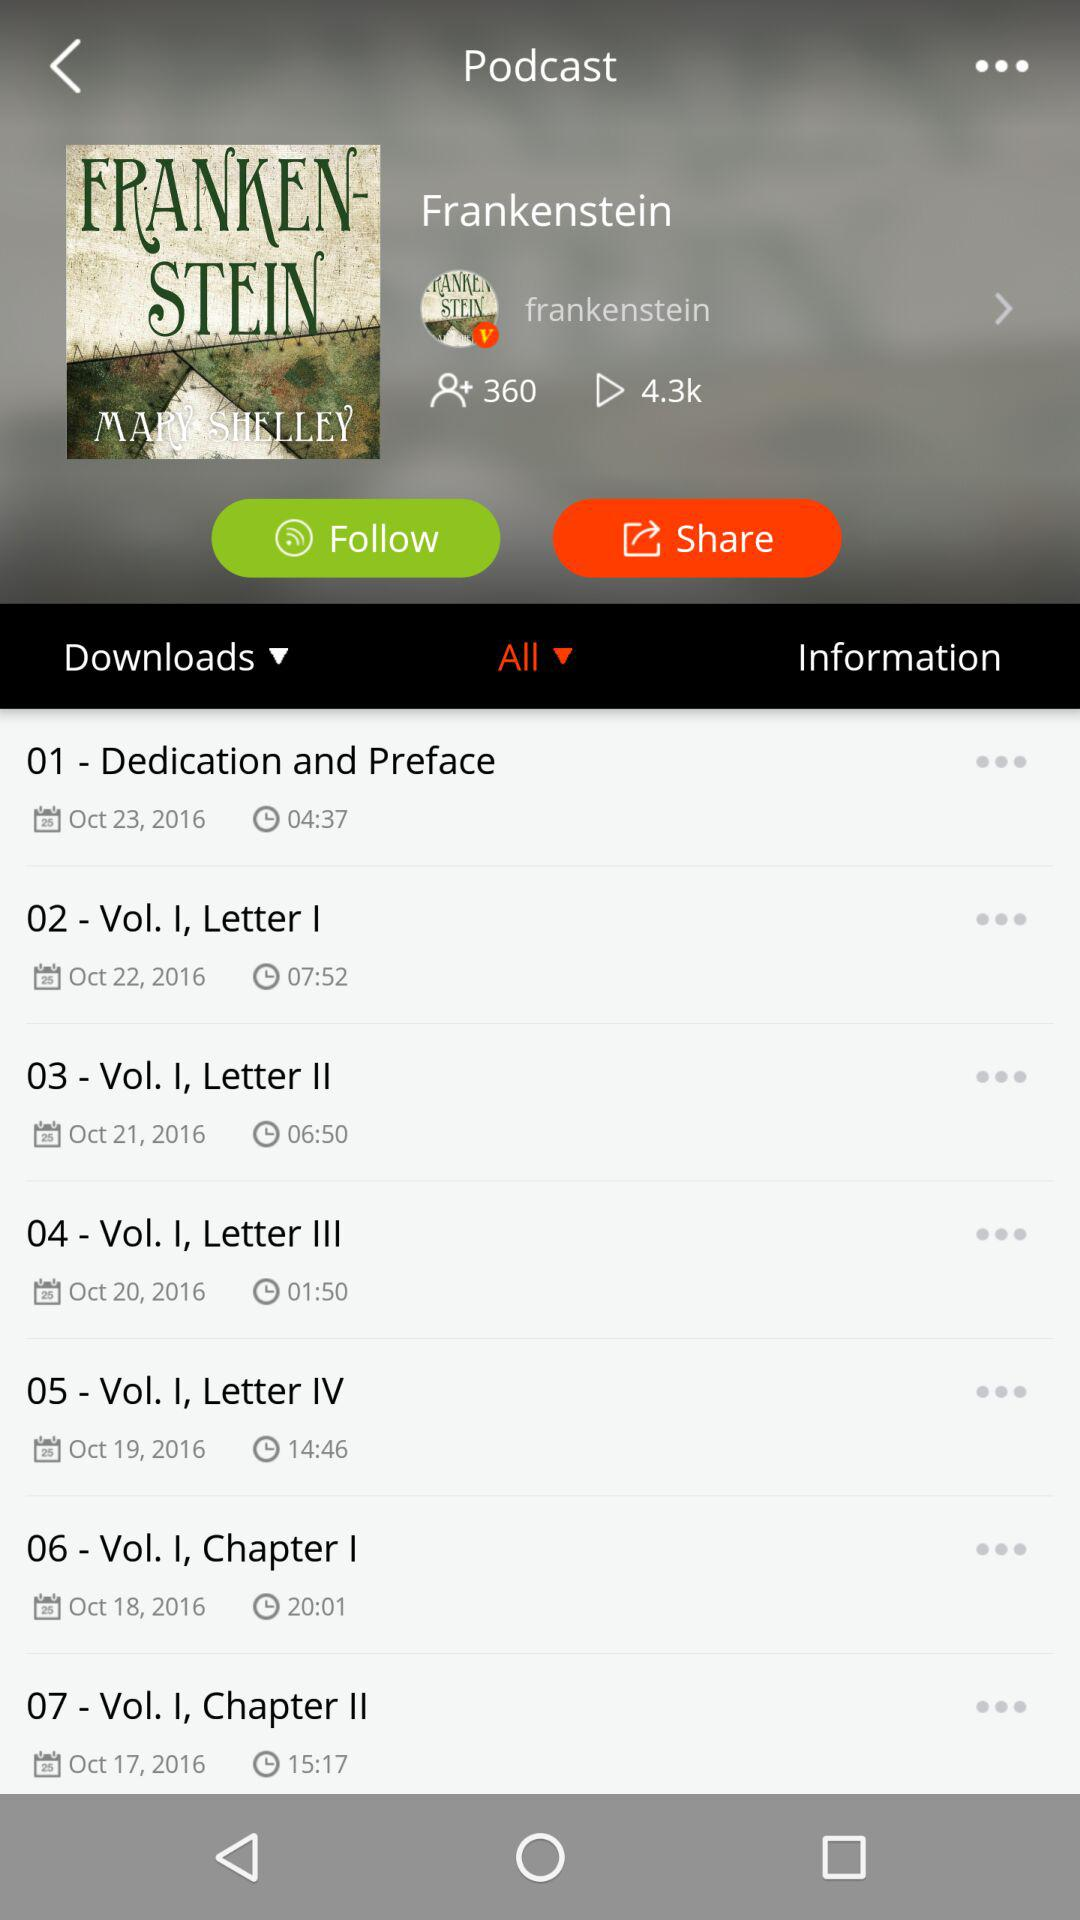How many of them played?
When the provided information is insufficient, respond with <no answer>. <no answer> 